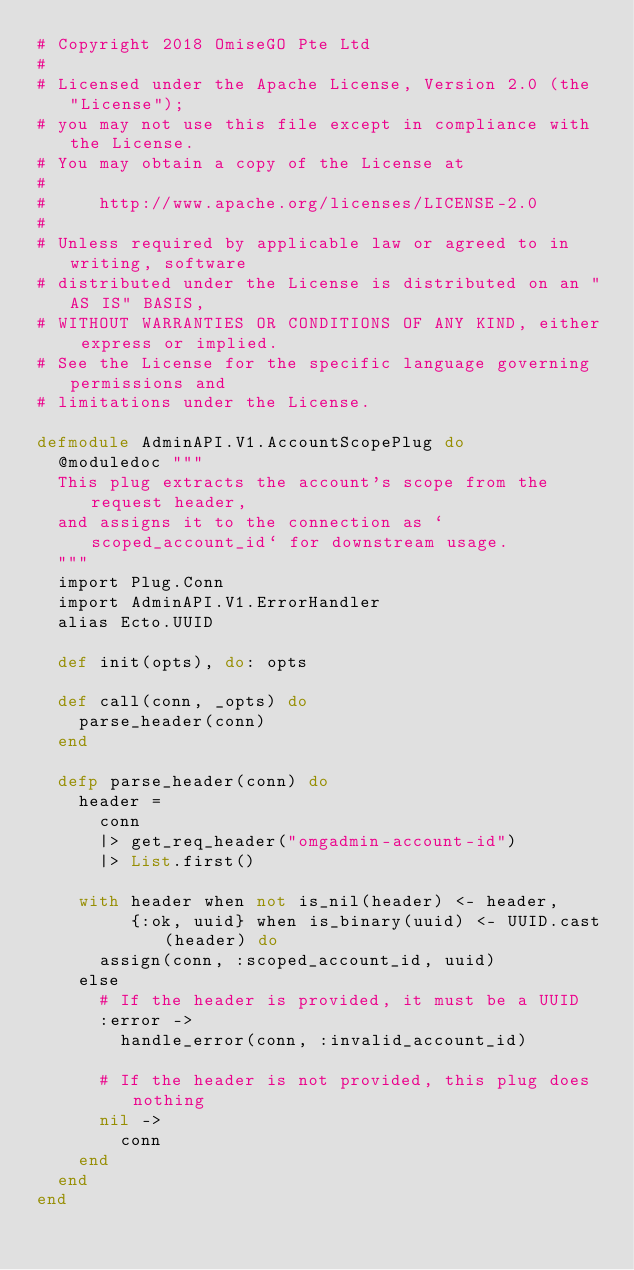Convert code to text. <code><loc_0><loc_0><loc_500><loc_500><_Elixir_># Copyright 2018 OmiseGO Pte Ltd
#
# Licensed under the Apache License, Version 2.0 (the "License");
# you may not use this file except in compliance with the License.
# You may obtain a copy of the License at
#
#     http://www.apache.org/licenses/LICENSE-2.0
#
# Unless required by applicable law or agreed to in writing, software
# distributed under the License is distributed on an "AS IS" BASIS,
# WITHOUT WARRANTIES OR CONDITIONS OF ANY KIND, either express or implied.
# See the License for the specific language governing permissions and
# limitations under the License.

defmodule AdminAPI.V1.AccountScopePlug do
  @moduledoc """
  This plug extracts the account's scope from the request header,
  and assigns it to the connection as `scoped_account_id` for downstream usage.
  """
  import Plug.Conn
  import AdminAPI.V1.ErrorHandler
  alias Ecto.UUID

  def init(opts), do: opts

  def call(conn, _opts) do
    parse_header(conn)
  end

  defp parse_header(conn) do
    header =
      conn
      |> get_req_header("omgadmin-account-id")
      |> List.first()

    with header when not is_nil(header) <- header,
         {:ok, uuid} when is_binary(uuid) <- UUID.cast(header) do
      assign(conn, :scoped_account_id, uuid)
    else
      # If the header is provided, it must be a UUID
      :error ->
        handle_error(conn, :invalid_account_id)

      # If the header is not provided, this plug does nothing
      nil ->
        conn
    end
  end
end
</code> 